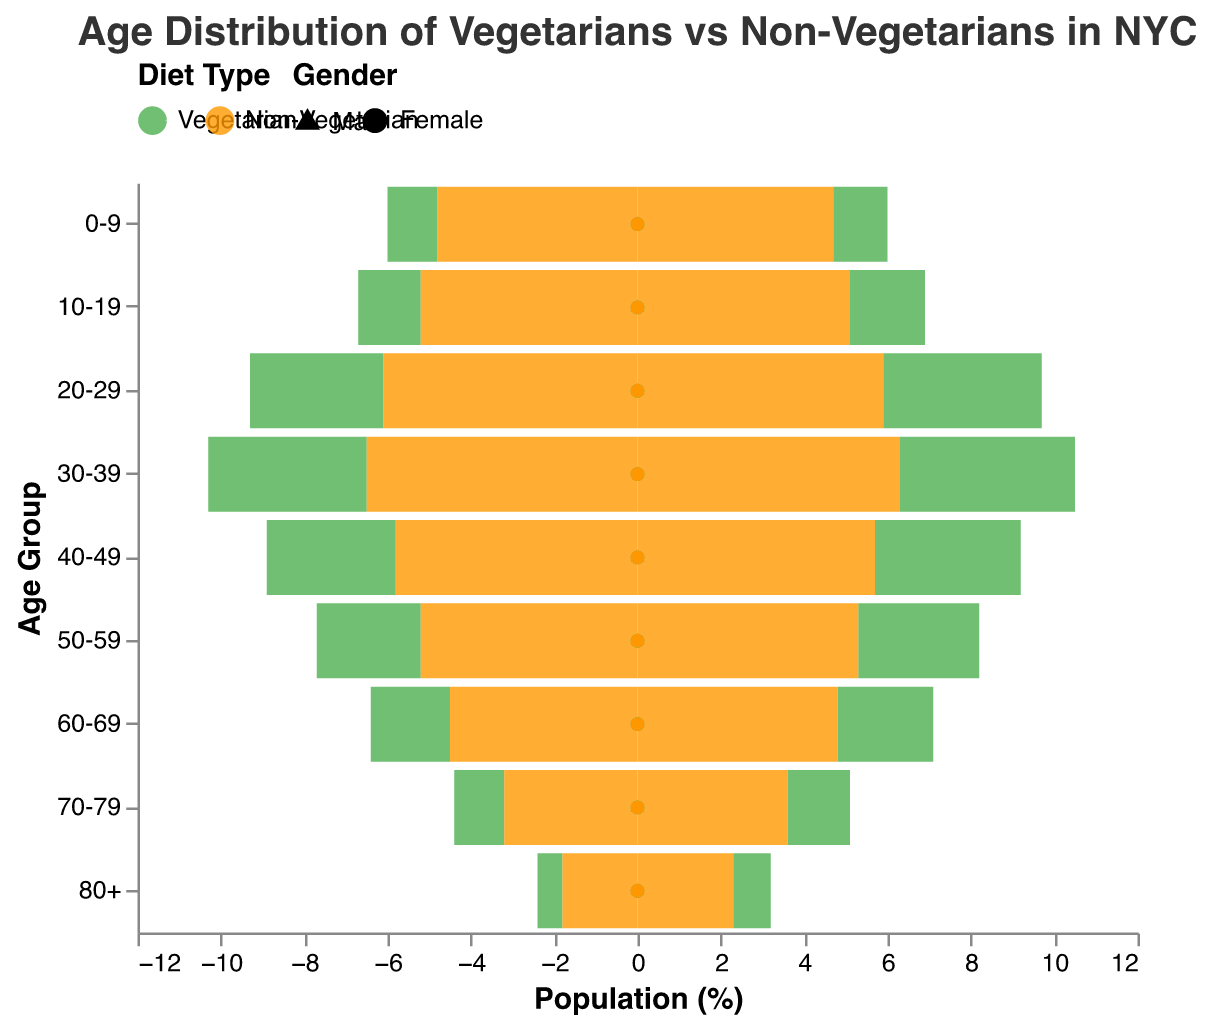Which diet type has a larger percentage of people in the 0-9 age group? Look at the bars corresponding to the 0-9 age group for both diet types. Non-Vegetarians have larger bars for both males (4.8%) and females (4.7%) compared to Vegetarians (1.2% for males and 1.3% for females).
Answer: Non-Vegetarians What is the percentage difference between vegetarian females and non-vegetarian females in the 30-39 age group? Vegetarian females hold 4.2%, and non-vegetarian females hold 6.3% in the 30-39 age group. The percentage difference is 6.3% - 4.2% = 2.1%.
Answer: 2.1% In which age group is the difference between vegetarian males and non-vegetarian males most significant? Compare the differences for each age group. The largest difference is in the 0-9 age group, where vegetarian males are 1.2% and non-vegetarian males are 4.8%, yielding a difference of 4.8% - 1.2% = 3.6%.
Answer: 0-9 Which gender has a higher percentage of vegetarians in the 60-69 age group? Compare the bars for males and females in the 60-69 age group among vegetarians. Females have 2.3%, and males have 1.9%.
Answer: Females Is the percentage of vegetarian females in the 70-79 age group higher or lower than non-vegetarian females in the same age group? In the 70-79 age group, the bar for vegetarian females indicates 1.5%, and the bar for non-vegetarian females indicates 3.6%.
Answer: Lower What is the total percentage of vegetarians in the 10-19 age group for both males and females? Add the percentages of vegetarian males and females in the 10-19 age group: 1.5% + 1.8% = 3.3%.
Answer: 3.3% Which age group has the smallest difference in percentage between vegetarian and non-vegetarian females? Calculate the difference for each age group and find the smallest difference. The smallest difference is in the 50-59 age group, where vegetarians are 2.9% and non-vegetarians are 5.3%, yielding a difference of 5.3% - 2.9% = 2.4%.
Answer: 50-59 How many age groups show a higher percentage of non-vegetarian males compared to non-vegetarian females? Compare the bars for non-vegetarian males and females in each age group. Non-vegetarian males have a higher percentage in 0-9, 10-19, and 20-29 age groups.
Answer: 3 